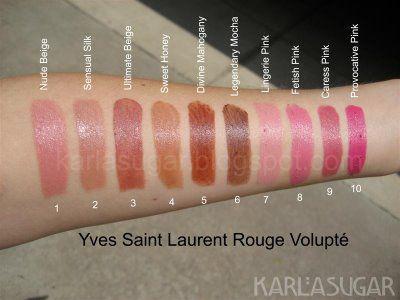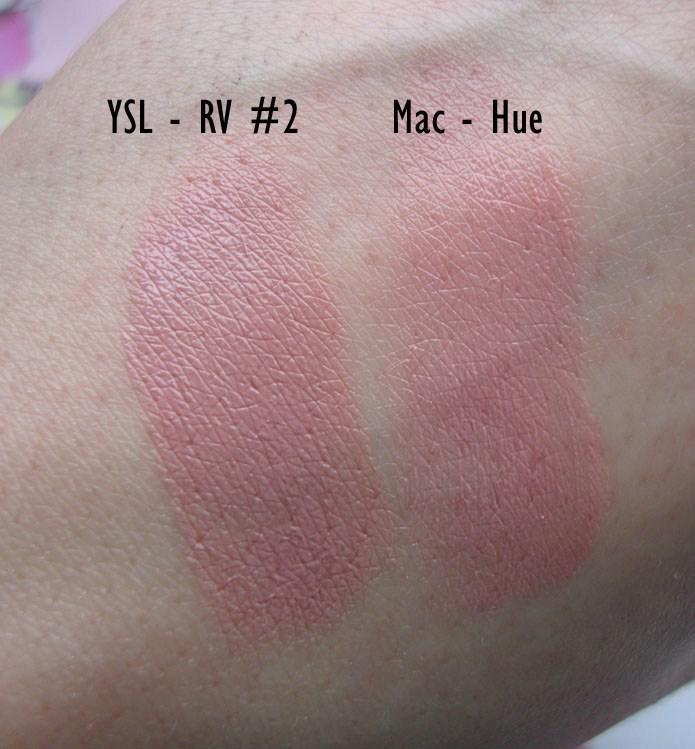The first image is the image on the left, the second image is the image on the right. For the images shown, is this caption "Both images in the pair show lipstick shades displayed on lips." true? Answer yes or no. No. 